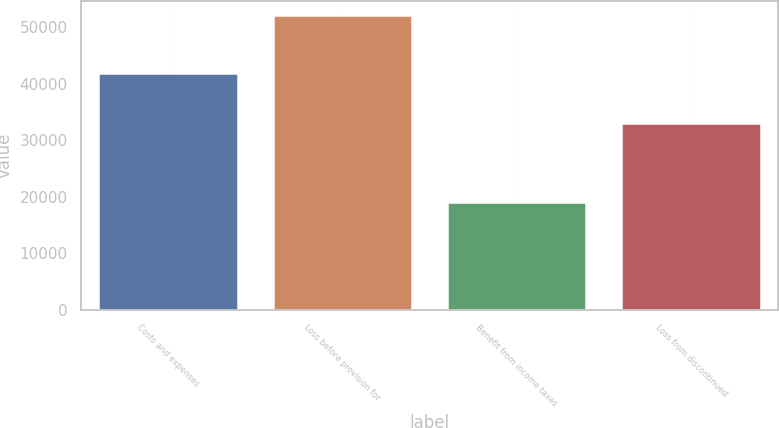Convert chart. <chart><loc_0><loc_0><loc_500><loc_500><bar_chart><fcel>Costs and expenses<fcel>Loss before provision for<fcel>Benefit from income taxes<fcel>Loss from discontinued<nl><fcel>41919<fcel>52131<fcel>19146<fcel>32985<nl></chart> 